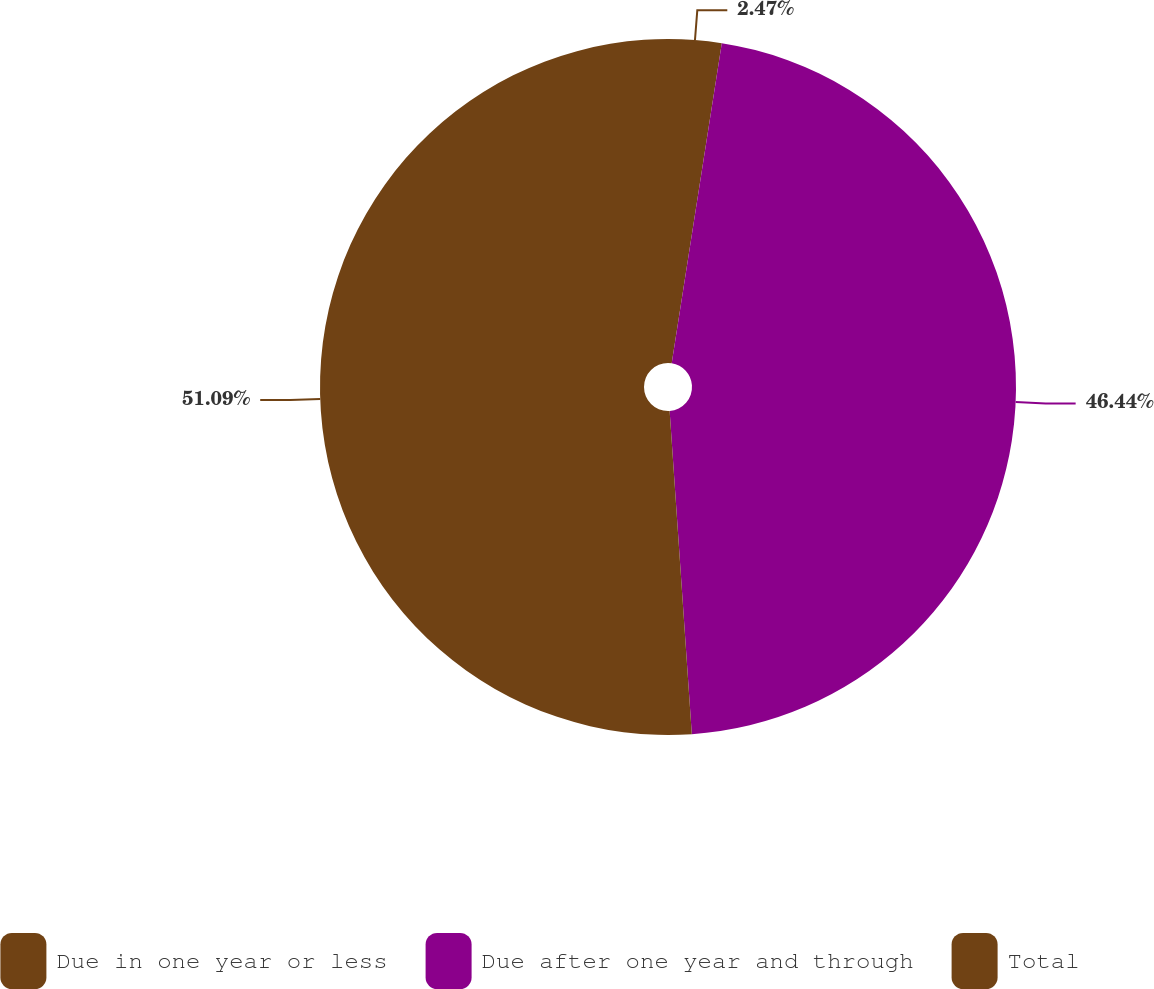<chart> <loc_0><loc_0><loc_500><loc_500><pie_chart><fcel>Due in one year or less<fcel>Due after one year and through<fcel>Total<nl><fcel>2.47%<fcel>46.44%<fcel>51.09%<nl></chart> 